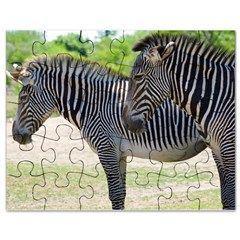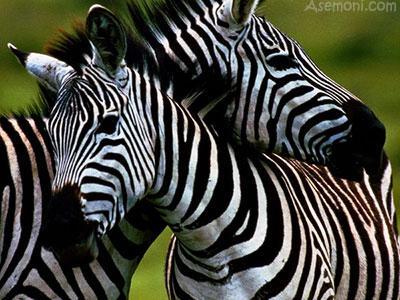The first image is the image on the left, the second image is the image on the right. Examine the images to the left and right. Is the description "Each image contains multiple zebras, and one image shows exactly two zebras posed with one's head over the other's back." accurate? Answer yes or no. Yes. The first image is the image on the left, the second image is the image on the right. Considering the images on both sides, is "The right image contains no more than two zebras." valid? Answer yes or no. Yes. 